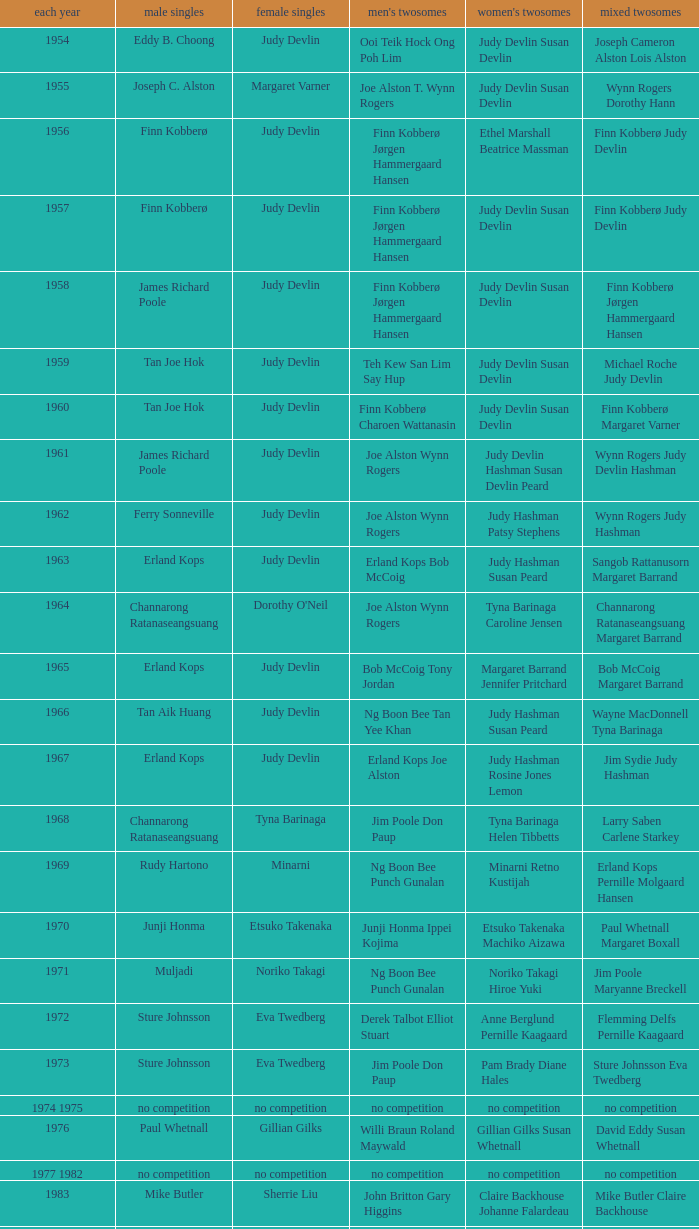Who were the men's doubles champions when the men's singles champion was muljadi? Ng Boon Bee Punch Gunalan. 